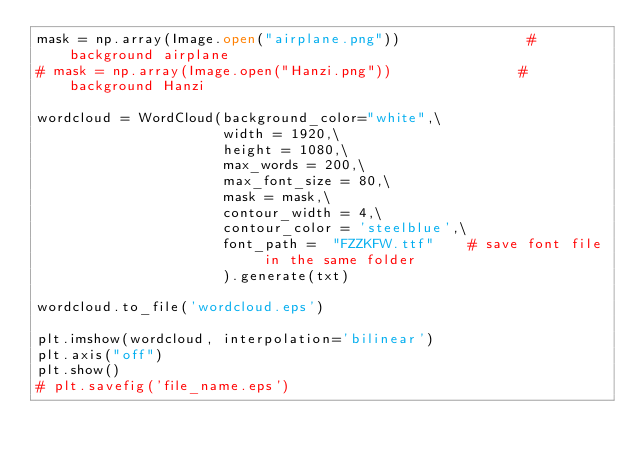<code> <loc_0><loc_0><loc_500><loc_500><_Python_>mask = np.array(Image.open("airplane.png"))               # background airplane
# mask = np.array(Image.open("Hanzi.png"))               # background Hanzi

wordcloud = WordCloud(background_color="white",\
                      width = 1920,\
                      height = 1080,\
                      max_words = 200,\
                      max_font_size = 80,\
                      mask = mask,\
                      contour_width = 4,\
                      contour_color = 'steelblue',\
                      font_path =  "FZZKFW.ttf"    # save font file in the same folder
                      ).generate(txt)

wordcloud.to_file('wordcloud.eps')

plt.imshow(wordcloud, interpolation='bilinear')
plt.axis("off")
plt.show()
# plt.savefig('file_name.eps')
</code> 